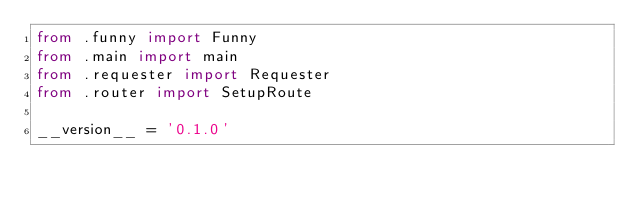Convert code to text. <code><loc_0><loc_0><loc_500><loc_500><_Python_>from .funny import Funny
from .main import main
from .requester import Requester
from .router import SetupRoute

__version__ = '0.1.0'
</code> 